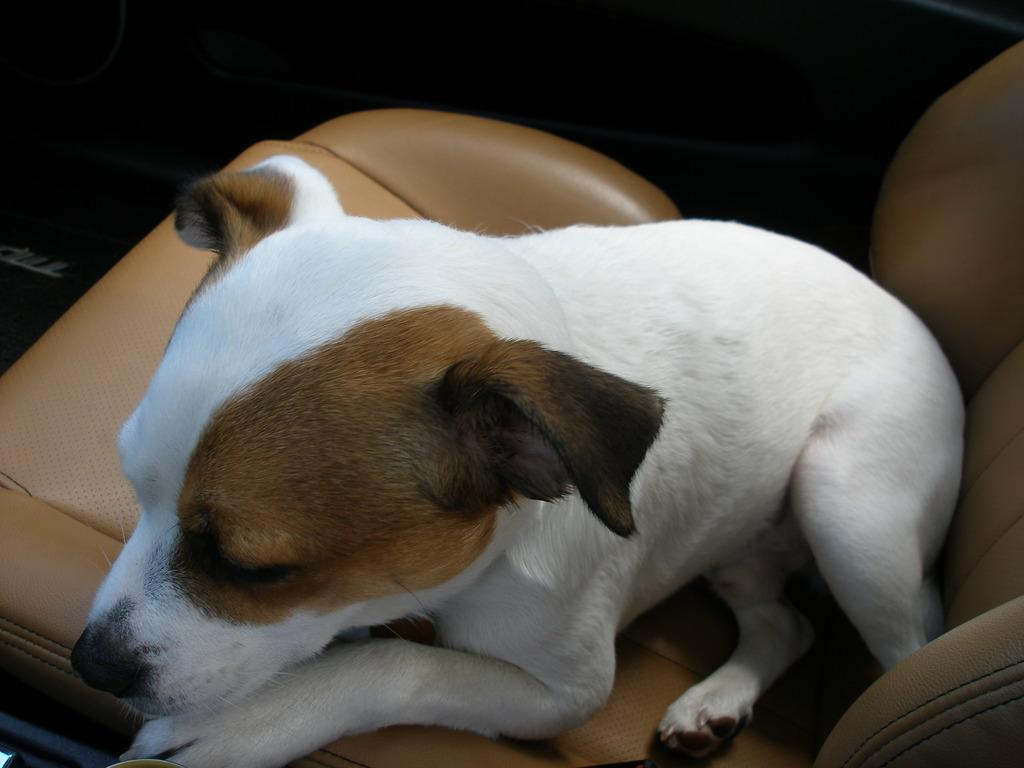What animal is present in the image? There is a dog in the image. What is the dog doing in the image? The dog is sitting on a seat. What can be observed about the lighting in the image? The background of the image is dark. How many children are participating in the protest in the image? There are no children or protest present in the image; it features a dog sitting on a seat with a dark background. 